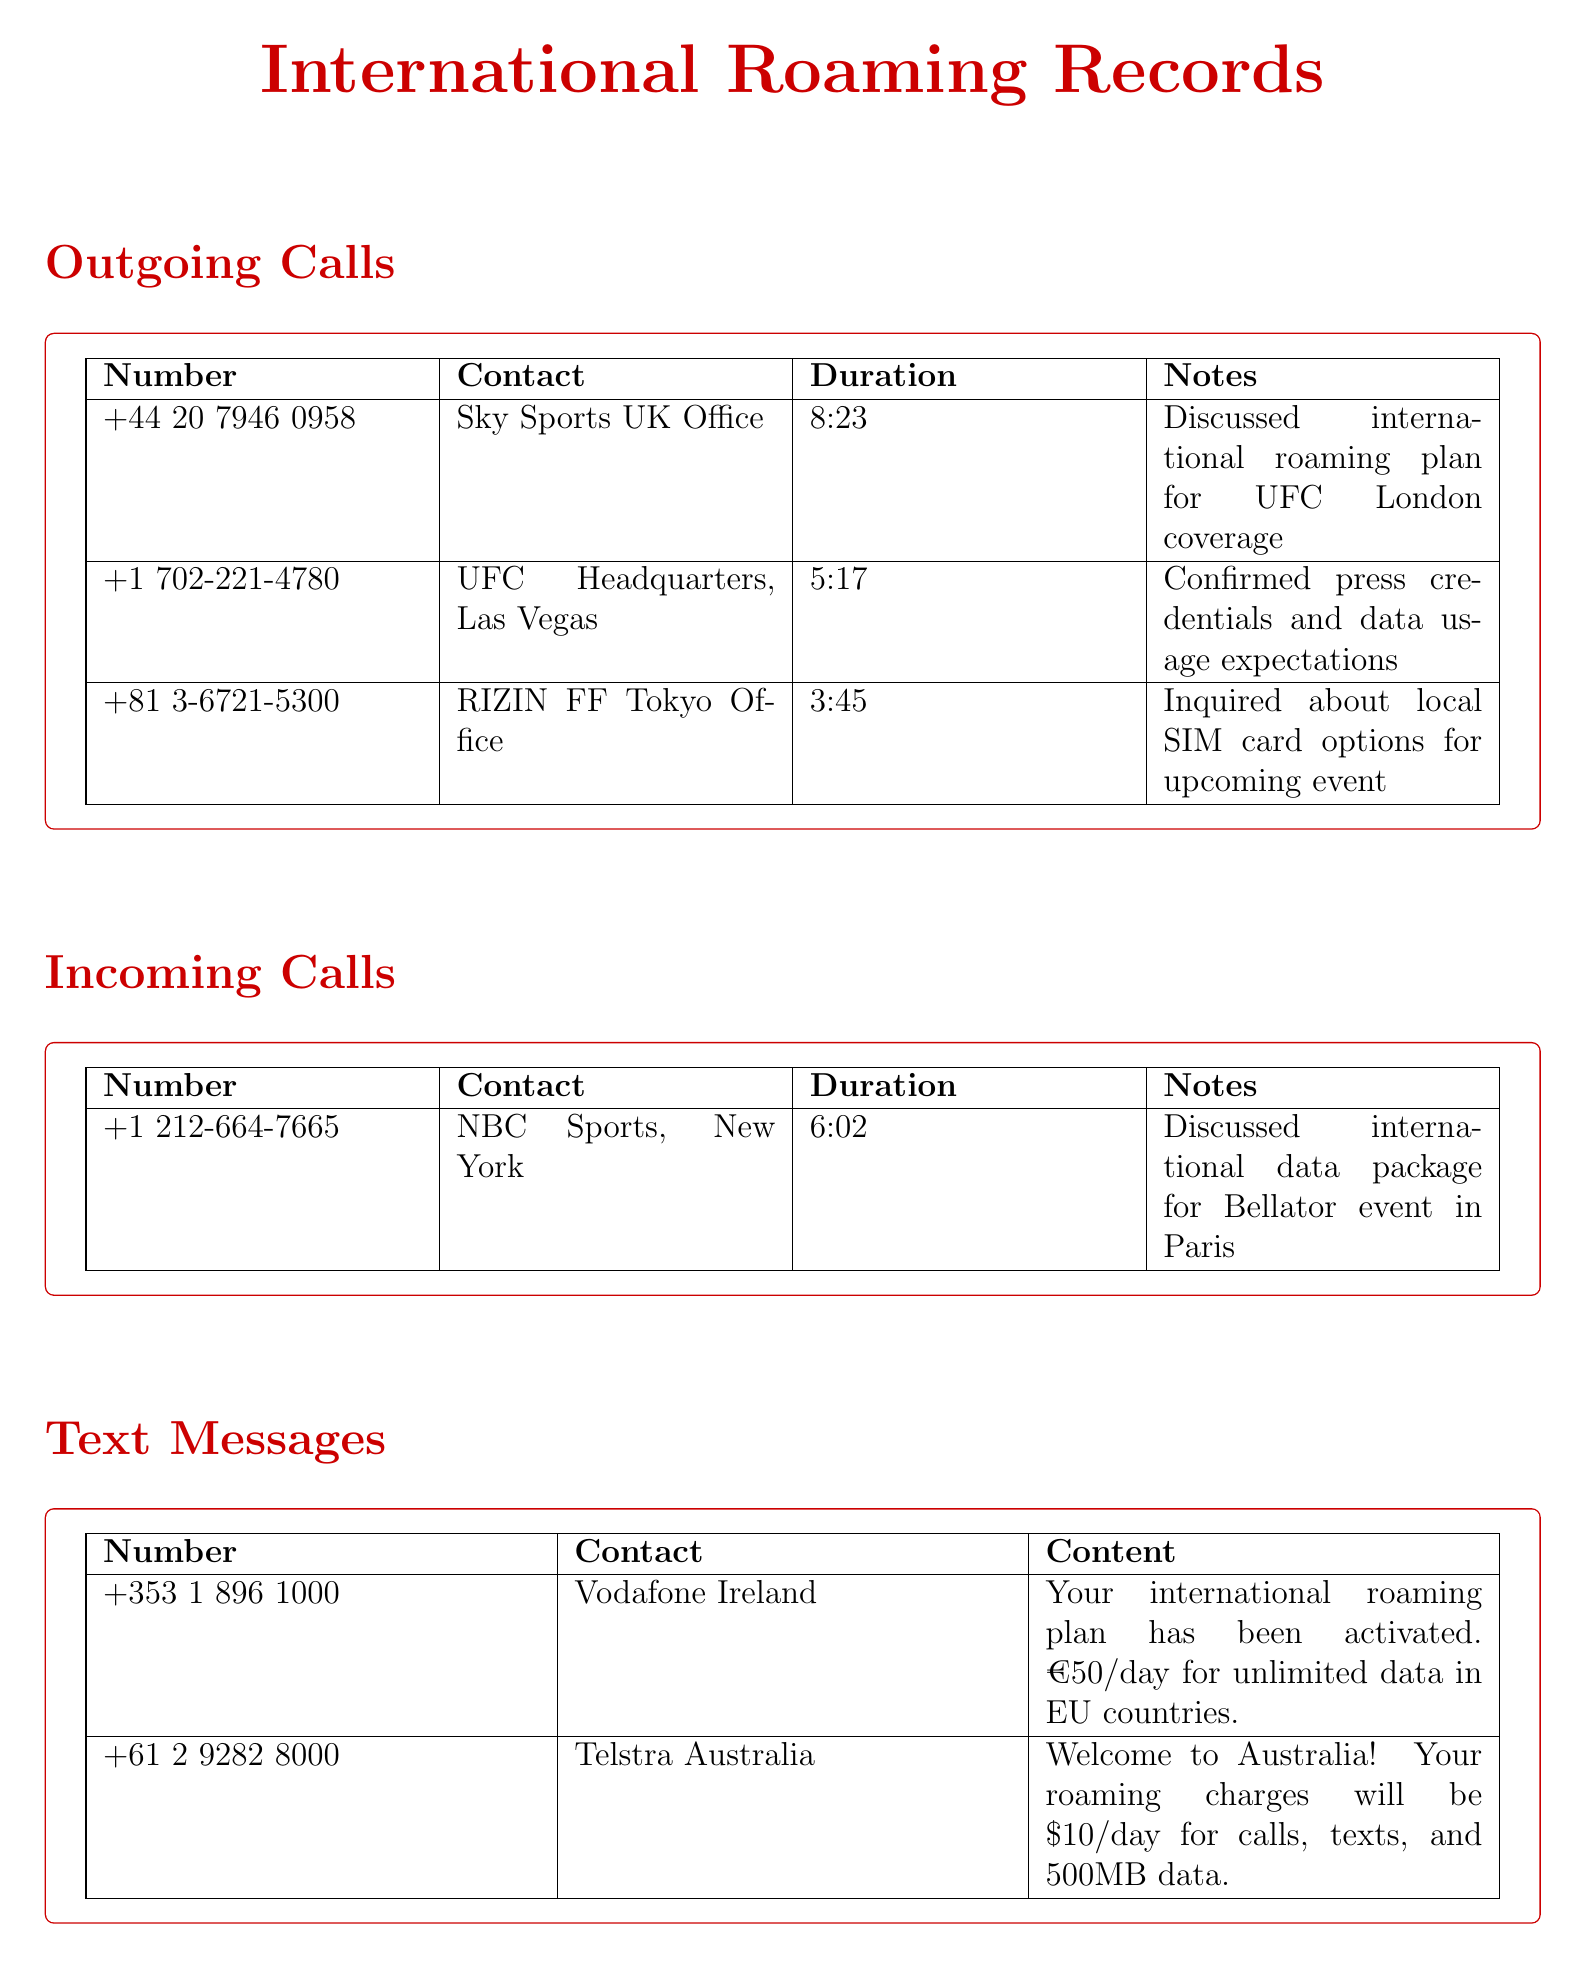what is the duration of the call to UFC Headquarters? The duration for the call to UFC Headquarters is listed in the table under Outgoing Calls. It shows 5 minutes and 17 seconds.
Answer: 5:17 who was the incoming call from NBC Sports? The incoming call from NBC Sports is noted in the Incoming Calls section. The contact is clearly specified as NBC Sports, New York.
Answer: NBC Sports, New York how much does the international roaming plan cost in EU countries? The cost of the international roaming plan in EU countries is mentioned in the text messages section from Vodafone Ireland. It states €50 per day.
Answer: €50/day what was discussed in the call to Sky Sports UK Office? The discussion topic for the call to Sky Sports UK Office is noted in the Outgoing Calls section, focusing on the international roaming plan for UFC London coverage.
Answer: International roaming plan for UFC London coverage how much data was consumed by Skype? The Data Usage section specifies the amount of data used by Skype, which shows it consumed 1.2 GB.
Answer: 1.2 GB what is the welcome message from Telstra Australia regarding roaming charges? The welcome message from Telstra Australia is included in the Text Messages section, indicating the roaming charges for calls, texts, and data while in Australia.
Answer: \$10/day for calls, texts, and 500MB data how long was the call to RIZIN FF Tokyo Office? The length of the call to RIZIN FF Tokyo Office appears in the Outgoing Calls segment. It lasted for 3 minutes and 45 seconds.
Answer: 3:45 what type of event was discussed in the call to NBC Sports? The type of event discussed in the call to NBC Sports is described in the notes section of the Incoming Calls. It refers to an international data package for a Bellator event.
Answer: Bellator event in Paris which app had the lowest data consumption? The app with the lowest data consumption is deduced by comparing usage amounts in the Data Usage section. Twitter shows a lower usage compared to Skype.
Answer: Twitter 